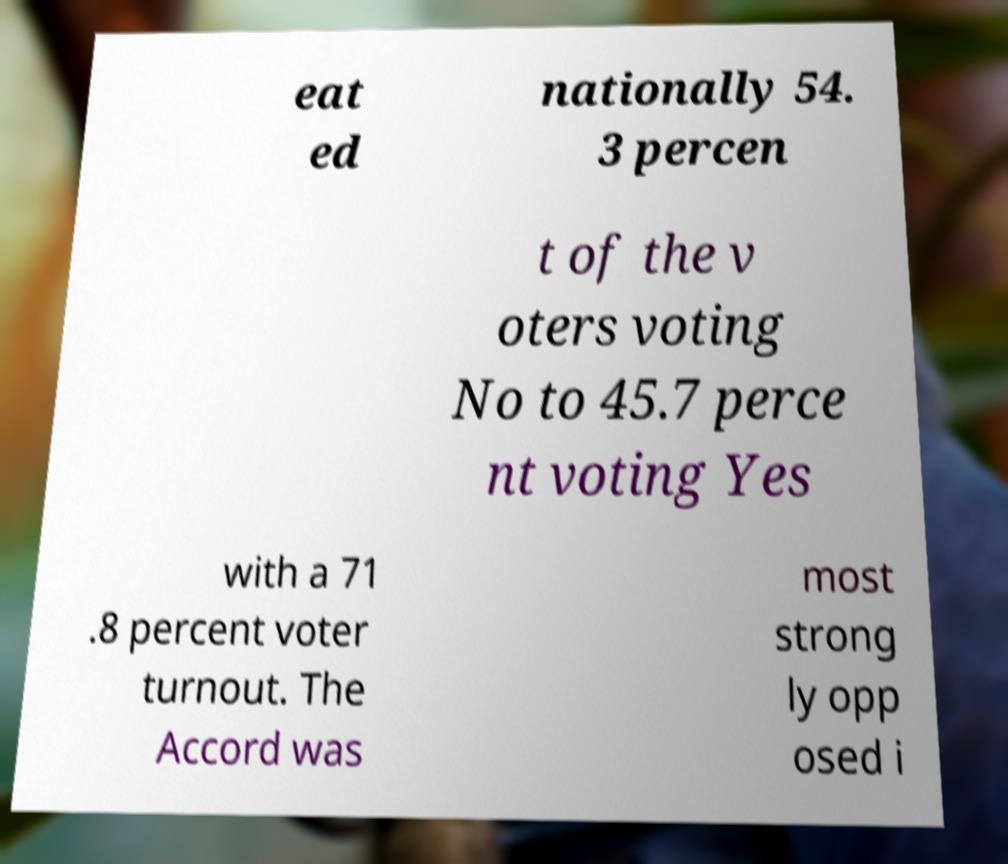Please identify and transcribe the text found in this image. eat ed nationally 54. 3 percen t of the v oters voting No to 45.7 perce nt voting Yes with a 71 .8 percent voter turnout. The Accord was most strong ly opp osed i 